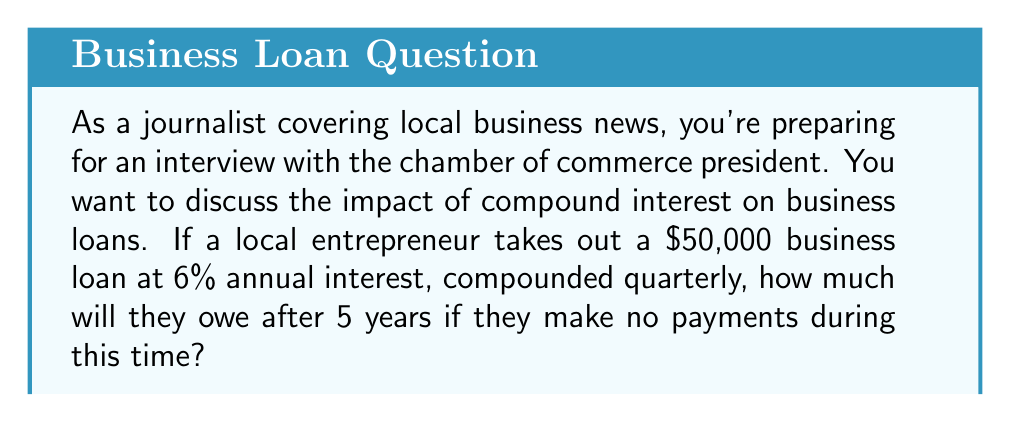What is the answer to this math problem? To solve this problem, we'll use the compound interest formula:

$$A = P(1 + \frac{r}{n})^{nt}$$

Where:
$A$ = Final amount
$P$ = Principal (initial loan amount)
$r$ = Annual interest rate (as a decimal)
$n$ = Number of times interest is compounded per year
$t$ = Number of years

Given:
$P = \$50,000$
$r = 0.06$ (6% expressed as a decimal)
$n = 4$ (compounded quarterly, so 4 times per year)
$t = 5$ years

Let's plug these values into the formula:

$$A = 50,000(1 + \frac{0.06}{4})^{4 \times 5}$$

$$A = 50,000(1 + 0.015)^{20}$$

$$A = 50,000(1.015)^{20}$$

Using a calculator or spreadsheet to compute this:

$$A = 50,000 \times 1.3478256$$

$$A = 67,391.28$$

Therefore, after 5 years, the entrepreneur will owe $67,391.28.
Answer: $67,391.28 